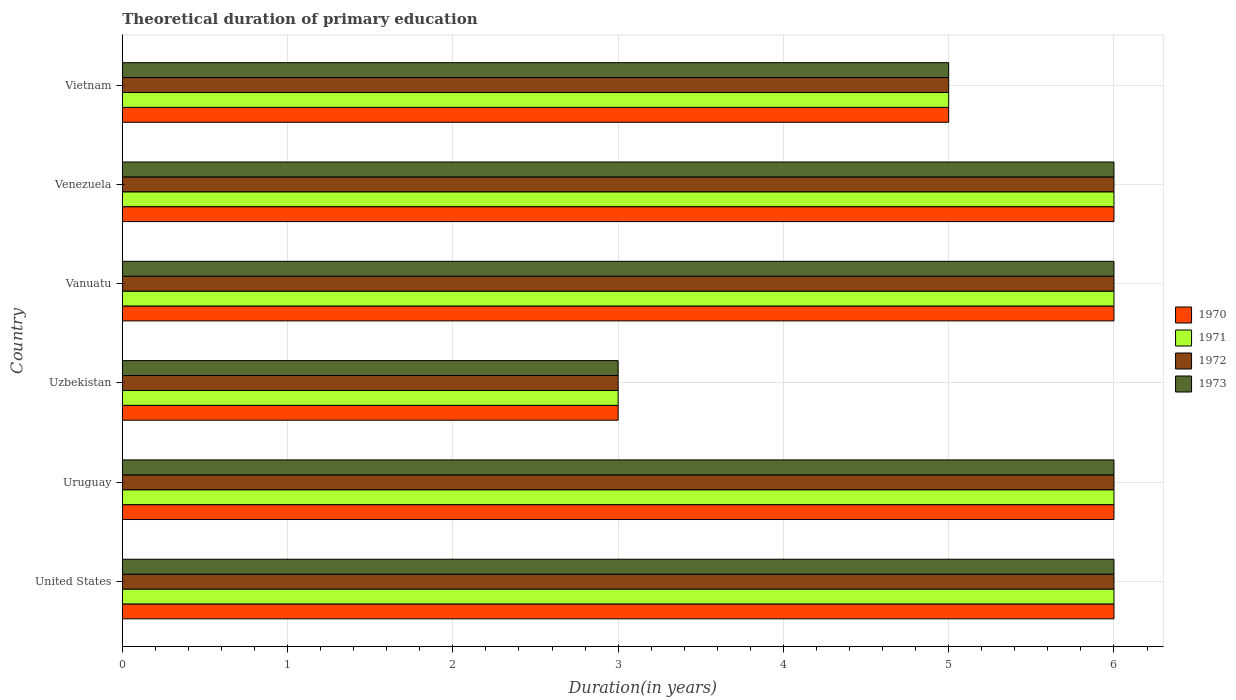How many different coloured bars are there?
Provide a succinct answer. 4. How many bars are there on the 1st tick from the top?
Offer a very short reply. 4. In how many cases, is the number of bars for a given country not equal to the number of legend labels?
Make the answer very short. 0. What is the total theoretical duration of primary education in 1970 in Vanuatu?
Make the answer very short. 6. Across all countries, what is the maximum total theoretical duration of primary education in 1973?
Your answer should be compact. 6. In which country was the total theoretical duration of primary education in 1973 maximum?
Your response must be concise. United States. In which country was the total theoretical duration of primary education in 1970 minimum?
Provide a short and direct response. Uzbekistan. What is the average total theoretical duration of primary education in 1970 per country?
Provide a succinct answer. 5.33. Is the total theoretical duration of primary education in 1971 in United States less than that in Uzbekistan?
Offer a terse response. No. What is the difference between the highest and the lowest total theoretical duration of primary education in 1973?
Provide a succinct answer. 3. In how many countries, is the total theoretical duration of primary education in 1972 greater than the average total theoretical duration of primary education in 1972 taken over all countries?
Provide a succinct answer. 4. Is it the case that in every country, the sum of the total theoretical duration of primary education in 1970 and total theoretical duration of primary education in 1973 is greater than the sum of total theoretical duration of primary education in 1972 and total theoretical duration of primary education in 1971?
Keep it short and to the point. No. What does the 1st bar from the bottom in Vanuatu represents?
Offer a terse response. 1970. Is it the case that in every country, the sum of the total theoretical duration of primary education in 1970 and total theoretical duration of primary education in 1972 is greater than the total theoretical duration of primary education in 1973?
Offer a terse response. Yes. How many bars are there?
Ensure brevity in your answer.  24. What is the difference between two consecutive major ticks on the X-axis?
Keep it short and to the point. 1. Does the graph contain grids?
Give a very brief answer. Yes. How many legend labels are there?
Your answer should be very brief. 4. What is the title of the graph?
Offer a terse response. Theoretical duration of primary education. What is the label or title of the X-axis?
Your answer should be compact. Duration(in years). What is the label or title of the Y-axis?
Provide a short and direct response. Country. What is the Duration(in years) of 1970 in United States?
Offer a terse response. 6. What is the Duration(in years) of 1972 in United States?
Your response must be concise. 6. What is the Duration(in years) in 1971 in Uruguay?
Ensure brevity in your answer.  6. What is the Duration(in years) in 1972 in Uruguay?
Give a very brief answer. 6. What is the Duration(in years) in 1973 in Uruguay?
Provide a succinct answer. 6. What is the Duration(in years) of 1970 in Uzbekistan?
Ensure brevity in your answer.  3. What is the Duration(in years) in 1971 in Uzbekistan?
Offer a very short reply. 3. What is the Duration(in years) of 1972 in Uzbekistan?
Provide a short and direct response. 3. What is the Duration(in years) of 1973 in Uzbekistan?
Your response must be concise. 3. What is the Duration(in years) of 1970 in Vanuatu?
Your answer should be very brief. 6. What is the Duration(in years) of 1971 in Vanuatu?
Your response must be concise. 6. What is the Duration(in years) in 1973 in Vanuatu?
Your response must be concise. 6. What is the Duration(in years) of 1970 in Venezuela?
Give a very brief answer. 6. What is the Duration(in years) of 1971 in Venezuela?
Your response must be concise. 6. Across all countries, what is the maximum Duration(in years) of 1970?
Offer a terse response. 6. Across all countries, what is the maximum Duration(in years) in 1972?
Offer a terse response. 6. Across all countries, what is the maximum Duration(in years) of 1973?
Keep it short and to the point. 6. Across all countries, what is the minimum Duration(in years) in 1970?
Provide a succinct answer. 3. Across all countries, what is the minimum Duration(in years) of 1971?
Keep it short and to the point. 3. Across all countries, what is the minimum Duration(in years) of 1972?
Provide a short and direct response. 3. What is the total Duration(in years) in 1970 in the graph?
Make the answer very short. 32. What is the total Duration(in years) of 1971 in the graph?
Provide a short and direct response. 32. What is the total Duration(in years) of 1973 in the graph?
Your answer should be compact. 32. What is the difference between the Duration(in years) in 1970 in United States and that in Uruguay?
Offer a very short reply. 0. What is the difference between the Duration(in years) in 1972 in United States and that in Uruguay?
Give a very brief answer. 0. What is the difference between the Duration(in years) of 1973 in United States and that in Uruguay?
Offer a terse response. 0. What is the difference between the Duration(in years) in 1973 in United States and that in Uzbekistan?
Keep it short and to the point. 3. What is the difference between the Duration(in years) of 1970 in United States and that in Vanuatu?
Your answer should be compact. 0. What is the difference between the Duration(in years) of 1973 in United States and that in Vanuatu?
Offer a very short reply. 0. What is the difference between the Duration(in years) of 1970 in United States and that in Venezuela?
Your answer should be very brief. 0. What is the difference between the Duration(in years) in 1972 in United States and that in Venezuela?
Ensure brevity in your answer.  0. What is the difference between the Duration(in years) of 1973 in United States and that in Venezuela?
Offer a terse response. 0. What is the difference between the Duration(in years) of 1970 in United States and that in Vietnam?
Offer a terse response. 1. What is the difference between the Duration(in years) of 1971 in United States and that in Vietnam?
Your answer should be very brief. 1. What is the difference between the Duration(in years) in 1973 in United States and that in Vietnam?
Keep it short and to the point. 1. What is the difference between the Duration(in years) in 1970 in Uruguay and that in Uzbekistan?
Your answer should be compact. 3. What is the difference between the Duration(in years) of 1971 in Uruguay and that in Uzbekistan?
Ensure brevity in your answer.  3. What is the difference between the Duration(in years) of 1970 in Uruguay and that in Vanuatu?
Your response must be concise. 0. What is the difference between the Duration(in years) in 1971 in Uruguay and that in Vanuatu?
Offer a very short reply. 0. What is the difference between the Duration(in years) of 1972 in Uruguay and that in Vanuatu?
Offer a very short reply. 0. What is the difference between the Duration(in years) of 1973 in Uruguay and that in Vanuatu?
Your answer should be compact. 0. What is the difference between the Duration(in years) of 1970 in Uruguay and that in Venezuela?
Keep it short and to the point. 0. What is the difference between the Duration(in years) of 1970 in Uzbekistan and that in Vanuatu?
Your answer should be compact. -3. What is the difference between the Duration(in years) in 1971 in Uzbekistan and that in Vanuatu?
Provide a short and direct response. -3. What is the difference between the Duration(in years) in 1973 in Uzbekistan and that in Vanuatu?
Your response must be concise. -3. What is the difference between the Duration(in years) of 1971 in Uzbekistan and that in Venezuela?
Your response must be concise. -3. What is the difference between the Duration(in years) in 1972 in Uzbekistan and that in Venezuela?
Your answer should be very brief. -3. What is the difference between the Duration(in years) of 1972 in Uzbekistan and that in Vietnam?
Keep it short and to the point. -2. What is the difference between the Duration(in years) in 1971 in Vanuatu and that in Venezuela?
Make the answer very short. 0. What is the difference between the Duration(in years) in 1973 in Vanuatu and that in Venezuela?
Ensure brevity in your answer.  0. What is the difference between the Duration(in years) of 1970 in Vanuatu and that in Vietnam?
Provide a succinct answer. 1. What is the difference between the Duration(in years) in 1971 in Vanuatu and that in Vietnam?
Your answer should be compact. 1. What is the difference between the Duration(in years) in 1970 in Venezuela and that in Vietnam?
Keep it short and to the point. 1. What is the difference between the Duration(in years) of 1971 in Venezuela and that in Vietnam?
Make the answer very short. 1. What is the difference between the Duration(in years) of 1970 in United States and the Duration(in years) of 1971 in Uruguay?
Your answer should be very brief. 0. What is the difference between the Duration(in years) of 1970 in United States and the Duration(in years) of 1972 in Uruguay?
Ensure brevity in your answer.  0. What is the difference between the Duration(in years) of 1971 in United States and the Duration(in years) of 1972 in Uruguay?
Give a very brief answer. 0. What is the difference between the Duration(in years) in 1972 in United States and the Duration(in years) in 1973 in Uruguay?
Keep it short and to the point. 0. What is the difference between the Duration(in years) of 1971 in United States and the Duration(in years) of 1973 in Uzbekistan?
Offer a terse response. 3. What is the difference between the Duration(in years) of 1972 in United States and the Duration(in years) of 1973 in Uzbekistan?
Keep it short and to the point. 3. What is the difference between the Duration(in years) of 1970 in United States and the Duration(in years) of 1971 in Vanuatu?
Provide a succinct answer. 0. What is the difference between the Duration(in years) of 1971 in United States and the Duration(in years) of 1972 in Vanuatu?
Provide a short and direct response. 0. What is the difference between the Duration(in years) in 1971 in United States and the Duration(in years) in 1973 in Vanuatu?
Offer a terse response. 0. What is the difference between the Duration(in years) of 1970 in United States and the Duration(in years) of 1971 in Venezuela?
Provide a short and direct response. 0. What is the difference between the Duration(in years) in 1972 in United States and the Duration(in years) in 1973 in Venezuela?
Give a very brief answer. 0. What is the difference between the Duration(in years) in 1970 in United States and the Duration(in years) in 1973 in Vietnam?
Your answer should be very brief. 1. What is the difference between the Duration(in years) of 1971 in United States and the Duration(in years) of 1973 in Vietnam?
Offer a very short reply. 1. What is the difference between the Duration(in years) of 1970 in Uruguay and the Duration(in years) of 1971 in Uzbekistan?
Provide a succinct answer. 3. What is the difference between the Duration(in years) of 1970 in Uruguay and the Duration(in years) of 1972 in Uzbekistan?
Your response must be concise. 3. What is the difference between the Duration(in years) in 1970 in Uruguay and the Duration(in years) in 1973 in Uzbekistan?
Make the answer very short. 3. What is the difference between the Duration(in years) of 1971 in Uruguay and the Duration(in years) of 1973 in Uzbekistan?
Give a very brief answer. 3. What is the difference between the Duration(in years) in 1972 in Uruguay and the Duration(in years) in 1973 in Uzbekistan?
Your response must be concise. 3. What is the difference between the Duration(in years) of 1970 in Uruguay and the Duration(in years) of 1971 in Vanuatu?
Keep it short and to the point. 0. What is the difference between the Duration(in years) in 1970 in Uruguay and the Duration(in years) in 1972 in Vanuatu?
Keep it short and to the point. 0. What is the difference between the Duration(in years) of 1970 in Uruguay and the Duration(in years) of 1973 in Vanuatu?
Make the answer very short. 0. What is the difference between the Duration(in years) of 1971 in Uruguay and the Duration(in years) of 1973 in Vanuatu?
Ensure brevity in your answer.  0. What is the difference between the Duration(in years) in 1972 in Uruguay and the Duration(in years) in 1973 in Vanuatu?
Your answer should be compact. 0. What is the difference between the Duration(in years) in 1970 in Uruguay and the Duration(in years) in 1971 in Venezuela?
Your answer should be compact. 0. What is the difference between the Duration(in years) of 1970 in Uruguay and the Duration(in years) of 1972 in Venezuela?
Your answer should be compact. 0. What is the difference between the Duration(in years) of 1971 in Uruguay and the Duration(in years) of 1973 in Venezuela?
Make the answer very short. 0. What is the difference between the Duration(in years) in 1972 in Uruguay and the Duration(in years) in 1973 in Venezuela?
Offer a very short reply. 0. What is the difference between the Duration(in years) in 1970 in Uruguay and the Duration(in years) in 1972 in Vietnam?
Offer a terse response. 1. What is the difference between the Duration(in years) in 1971 in Uruguay and the Duration(in years) in 1973 in Vietnam?
Your answer should be very brief. 1. What is the difference between the Duration(in years) in 1970 in Uzbekistan and the Duration(in years) in 1971 in Vanuatu?
Offer a terse response. -3. What is the difference between the Duration(in years) in 1970 in Uzbekistan and the Duration(in years) in 1972 in Vanuatu?
Ensure brevity in your answer.  -3. What is the difference between the Duration(in years) in 1971 in Uzbekistan and the Duration(in years) in 1973 in Vanuatu?
Offer a terse response. -3. What is the difference between the Duration(in years) in 1972 in Uzbekistan and the Duration(in years) in 1973 in Vanuatu?
Keep it short and to the point. -3. What is the difference between the Duration(in years) in 1970 in Uzbekistan and the Duration(in years) in 1971 in Venezuela?
Give a very brief answer. -3. What is the difference between the Duration(in years) in 1970 in Uzbekistan and the Duration(in years) in 1972 in Venezuela?
Your answer should be very brief. -3. What is the difference between the Duration(in years) in 1970 in Uzbekistan and the Duration(in years) in 1973 in Venezuela?
Provide a succinct answer. -3. What is the difference between the Duration(in years) in 1971 in Uzbekistan and the Duration(in years) in 1972 in Venezuela?
Offer a terse response. -3. What is the difference between the Duration(in years) of 1970 in Uzbekistan and the Duration(in years) of 1971 in Vietnam?
Give a very brief answer. -2. What is the difference between the Duration(in years) in 1970 in Uzbekistan and the Duration(in years) in 1972 in Vietnam?
Keep it short and to the point. -2. What is the difference between the Duration(in years) of 1971 in Uzbekistan and the Duration(in years) of 1972 in Vietnam?
Offer a terse response. -2. What is the difference between the Duration(in years) of 1971 in Uzbekistan and the Duration(in years) of 1973 in Vietnam?
Offer a terse response. -2. What is the difference between the Duration(in years) in 1972 in Uzbekistan and the Duration(in years) in 1973 in Vietnam?
Offer a terse response. -2. What is the difference between the Duration(in years) of 1970 in Vanuatu and the Duration(in years) of 1972 in Venezuela?
Give a very brief answer. 0. What is the difference between the Duration(in years) in 1970 in Vanuatu and the Duration(in years) in 1973 in Vietnam?
Provide a short and direct response. 1. What is the difference between the Duration(in years) in 1971 in Vanuatu and the Duration(in years) in 1972 in Vietnam?
Ensure brevity in your answer.  1. What is the difference between the Duration(in years) in 1972 in Vanuatu and the Duration(in years) in 1973 in Vietnam?
Your answer should be compact. 1. What is the difference between the Duration(in years) in 1971 in Venezuela and the Duration(in years) in 1972 in Vietnam?
Your answer should be compact. 1. What is the difference between the Duration(in years) of 1971 in Venezuela and the Duration(in years) of 1973 in Vietnam?
Your response must be concise. 1. What is the difference between the Duration(in years) in 1972 in Venezuela and the Duration(in years) in 1973 in Vietnam?
Offer a very short reply. 1. What is the average Duration(in years) of 1970 per country?
Your answer should be compact. 5.33. What is the average Duration(in years) in 1971 per country?
Ensure brevity in your answer.  5.33. What is the average Duration(in years) in 1972 per country?
Your response must be concise. 5.33. What is the average Duration(in years) of 1973 per country?
Your response must be concise. 5.33. What is the difference between the Duration(in years) in 1970 and Duration(in years) in 1971 in United States?
Make the answer very short. 0. What is the difference between the Duration(in years) of 1970 and Duration(in years) of 1973 in United States?
Provide a short and direct response. 0. What is the difference between the Duration(in years) of 1971 and Duration(in years) of 1972 in United States?
Give a very brief answer. 0. What is the difference between the Duration(in years) of 1972 and Duration(in years) of 1973 in United States?
Your answer should be very brief. 0. What is the difference between the Duration(in years) in 1970 and Duration(in years) in 1971 in Uruguay?
Ensure brevity in your answer.  0. What is the difference between the Duration(in years) in 1970 and Duration(in years) in 1972 in Uruguay?
Your answer should be very brief. 0. What is the difference between the Duration(in years) of 1971 and Duration(in years) of 1973 in Uruguay?
Offer a very short reply. 0. What is the difference between the Duration(in years) in 1972 and Duration(in years) in 1973 in Uruguay?
Offer a very short reply. 0. What is the difference between the Duration(in years) in 1970 and Duration(in years) in 1972 in Uzbekistan?
Make the answer very short. 0. What is the difference between the Duration(in years) in 1970 and Duration(in years) in 1973 in Uzbekistan?
Offer a terse response. 0. What is the difference between the Duration(in years) in 1971 and Duration(in years) in 1972 in Uzbekistan?
Provide a succinct answer. 0. What is the difference between the Duration(in years) of 1970 and Duration(in years) of 1971 in Vanuatu?
Offer a very short reply. 0. What is the difference between the Duration(in years) in 1970 and Duration(in years) in 1972 in Vanuatu?
Provide a short and direct response. 0. What is the difference between the Duration(in years) of 1970 and Duration(in years) of 1973 in Vanuatu?
Ensure brevity in your answer.  0. What is the difference between the Duration(in years) of 1971 and Duration(in years) of 1972 in Vanuatu?
Keep it short and to the point. 0. What is the difference between the Duration(in years) in 1970 and Duration(in years) in 1972 in Venezuela?
Offer a terse response. 0. What is the difference between the Duration(in years) in 1970 and Duration(in years) in 1973 in Venezuela?
Your answer should be very brief. 0. What is the difference between the Duration(in years) of 1971 and Duration(in years) of 1972 in Venezuela?
Provide a short and direct response. 0. What is the difference between the Duration(in years) in 1971 and Duration(in years) in 1973 in Venezuela?
Keep it short and to the point. 0. What is the difference between the Duration(in years) in 1970 and Duration(in years) in 1971 in Vietnam?
Your response must be concise. 0. What is the difference between the Duration(in years) in 1970 and Duration(in years) in 1972 in Vietnam?
Give a very brief answer. 0. What is the difference between the Duration(in years) in 1970 and Duration(in years) in 1973 in Vietnam?
Offer a terse response. 0. What is the difference between the Duration(in years) of 1972 and Duration(in years) of 1973 in Vietnam?
Provide a succinct answer. 0. What is the ratio of the Duration(in years) of 1971 in United States to that in Uruguay?
Offer a terse response. 1. What is the ratio of the Duration(in years) of 1972 in United States to that in Uruguay?
Ensure brevity in your answer.  1. What is the ratio of the Duration(in years) in 1970 in United States to that in Uzbekistan?
Provide a succinct answer. 2. What is the ratio of the Duration(in years) in 1971 in United States to that in Uzbekistan?
Offer a terse response. 2. What is the ratio of the Duration(in years) in 1972 in United States to that in Uzbekistan?
Your answer should be compact. 2. What is the ratio of the Duration(in years) in 1971 in United States to that in Venezuela?
Your response must be concise. 1. What is the ratio of the Duration(in years) in 1971 in United States to that in Vietnam?
Your response must be concise. 1.2. What is the ratio of the Duration(in years) of 1972 in United States to that in Vietnam?
Give a very brief answer. 1.2. What is the ratio of the Duration(in years) in 1971 in Uruguay to that in Uzbekistan?
Provide a short and direct response. 2. What is the ratio of the Duration(in years) of 1970 in Uruguay to that in Vanuatu?
Your response must be concise. 1. What is the ratio of the Duration(in years) of 1971 in Uruguay to that in Vanuatu?
Your answer should be very brief. 1. What is the ratio of the Duration(in years) of 1972 in Uruguay to that in Vanuatu?
Give a very brief answer. 1. What is the ratio of the Duration(in years) of 1973 in Uruguay to that in Venezuela?
Your response must be concise. 1. What is the ratio of the Duration(in years) in 1971 in Uruguay to that in Vietnam?
Keep it short and to the point. 1.2. What is the ratio of the Duration(in years) of 1970 in Uzbekistan to that in Vanuatu?
Provide a short and direct response. 0.5. What is the ratio of the Duration(in years) of 1972 in Uzbekistan to that in Vanuatu?
Ensure brevity in your answer.  0.5. What is the ratio of the Duration(in years) in 1973 in Uzbekistan to that in Vanuatu?
Your response must be concise. 0.5. What is the ratio of the Duration(in years) in 1970 in Uzbekistan to that in Venezuela?
Your response must be concise. 0.5. What is the ratio of the Duration(in years) in 1972 in Uzbekistan to that in Venezuela?
Your response must be concise. 0.5. What is the ratio of the Duration(in years) in 1973 in Uzbekistan to that in Venezuela?
Your answer should be compact. 0.5. What is the ratio of the Duration(in years) in 1971 in Uzbekistan to that in Vietnam?
Keep it short and to the point. 0.6. What is the ratio of the Duration(in years) in 1971 in Vanuatu to that in Venezuela?
Ensure brevity in your answer.  1. What is the ratio of the Duration(in years) in 1973 in Vanuatu to that in Venezuela?
Provide a succinct answer. 1. What is the ratio of the Duration(in years) in 1970 in Vanuatu to that in Vietnam?
Provide a succinct answer. 1.2. What is the ratio of the Duration(in years) in 1973 in Vanuatu to that in Vietnam?
Offer a very short reply. 1.2. What is the ratio of the Duration(in years) of 1970 in Venezuela to that in Vietnam?
Give a very brief answer. 1.2. What is the ratio of the Duration(in years) of 1973 in Venezuela to that in Vietnam?
Provide a succinct answer. 1.2. What is the difference between the highest and the second highest Duration(in years) in 1970?
Give a very brief answer. 0. What is the difference between the highest and the second highest Duration(in years) in 1972?
Offer a terse response. 0. What is the difference between the highest and the second highest Duration(in years) in 1973?
Your answer should be compact. 0. What is the difference between the highest and the lowest Duration(in years) in 1971?
Keep it short and to the point. 3. 